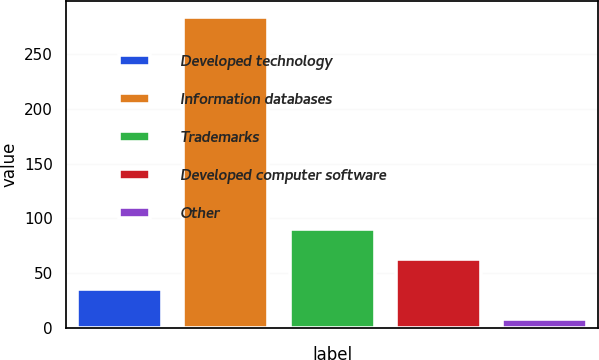Convert chart. <chart><loc_0><loc_0><loc_500><loc_500><bar_chart><fcel>Developed technology<fcel>Information databases<fcel>Trademarks<fcel>Developed computer software<fcel>Other<nl><fcel>35.14<fcel>283.9<fcel>90.42<fcel>62.78<fcel>7.5<nl></chart> 